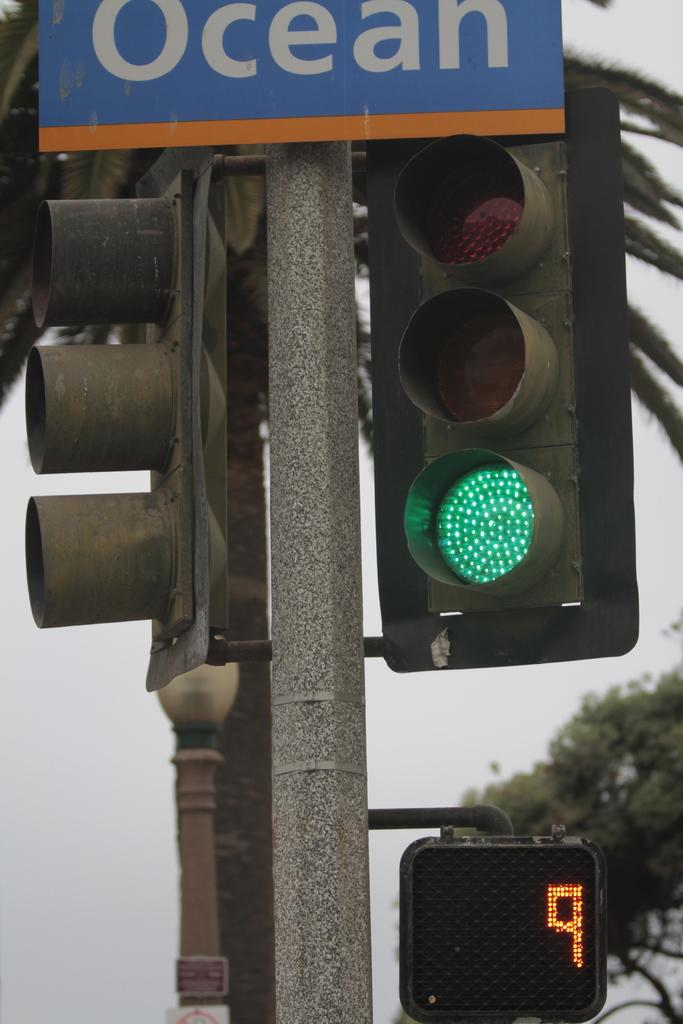<image>
Write a terse but informative summary of the picture. A stop light glowing green on a street named "Ocean." 